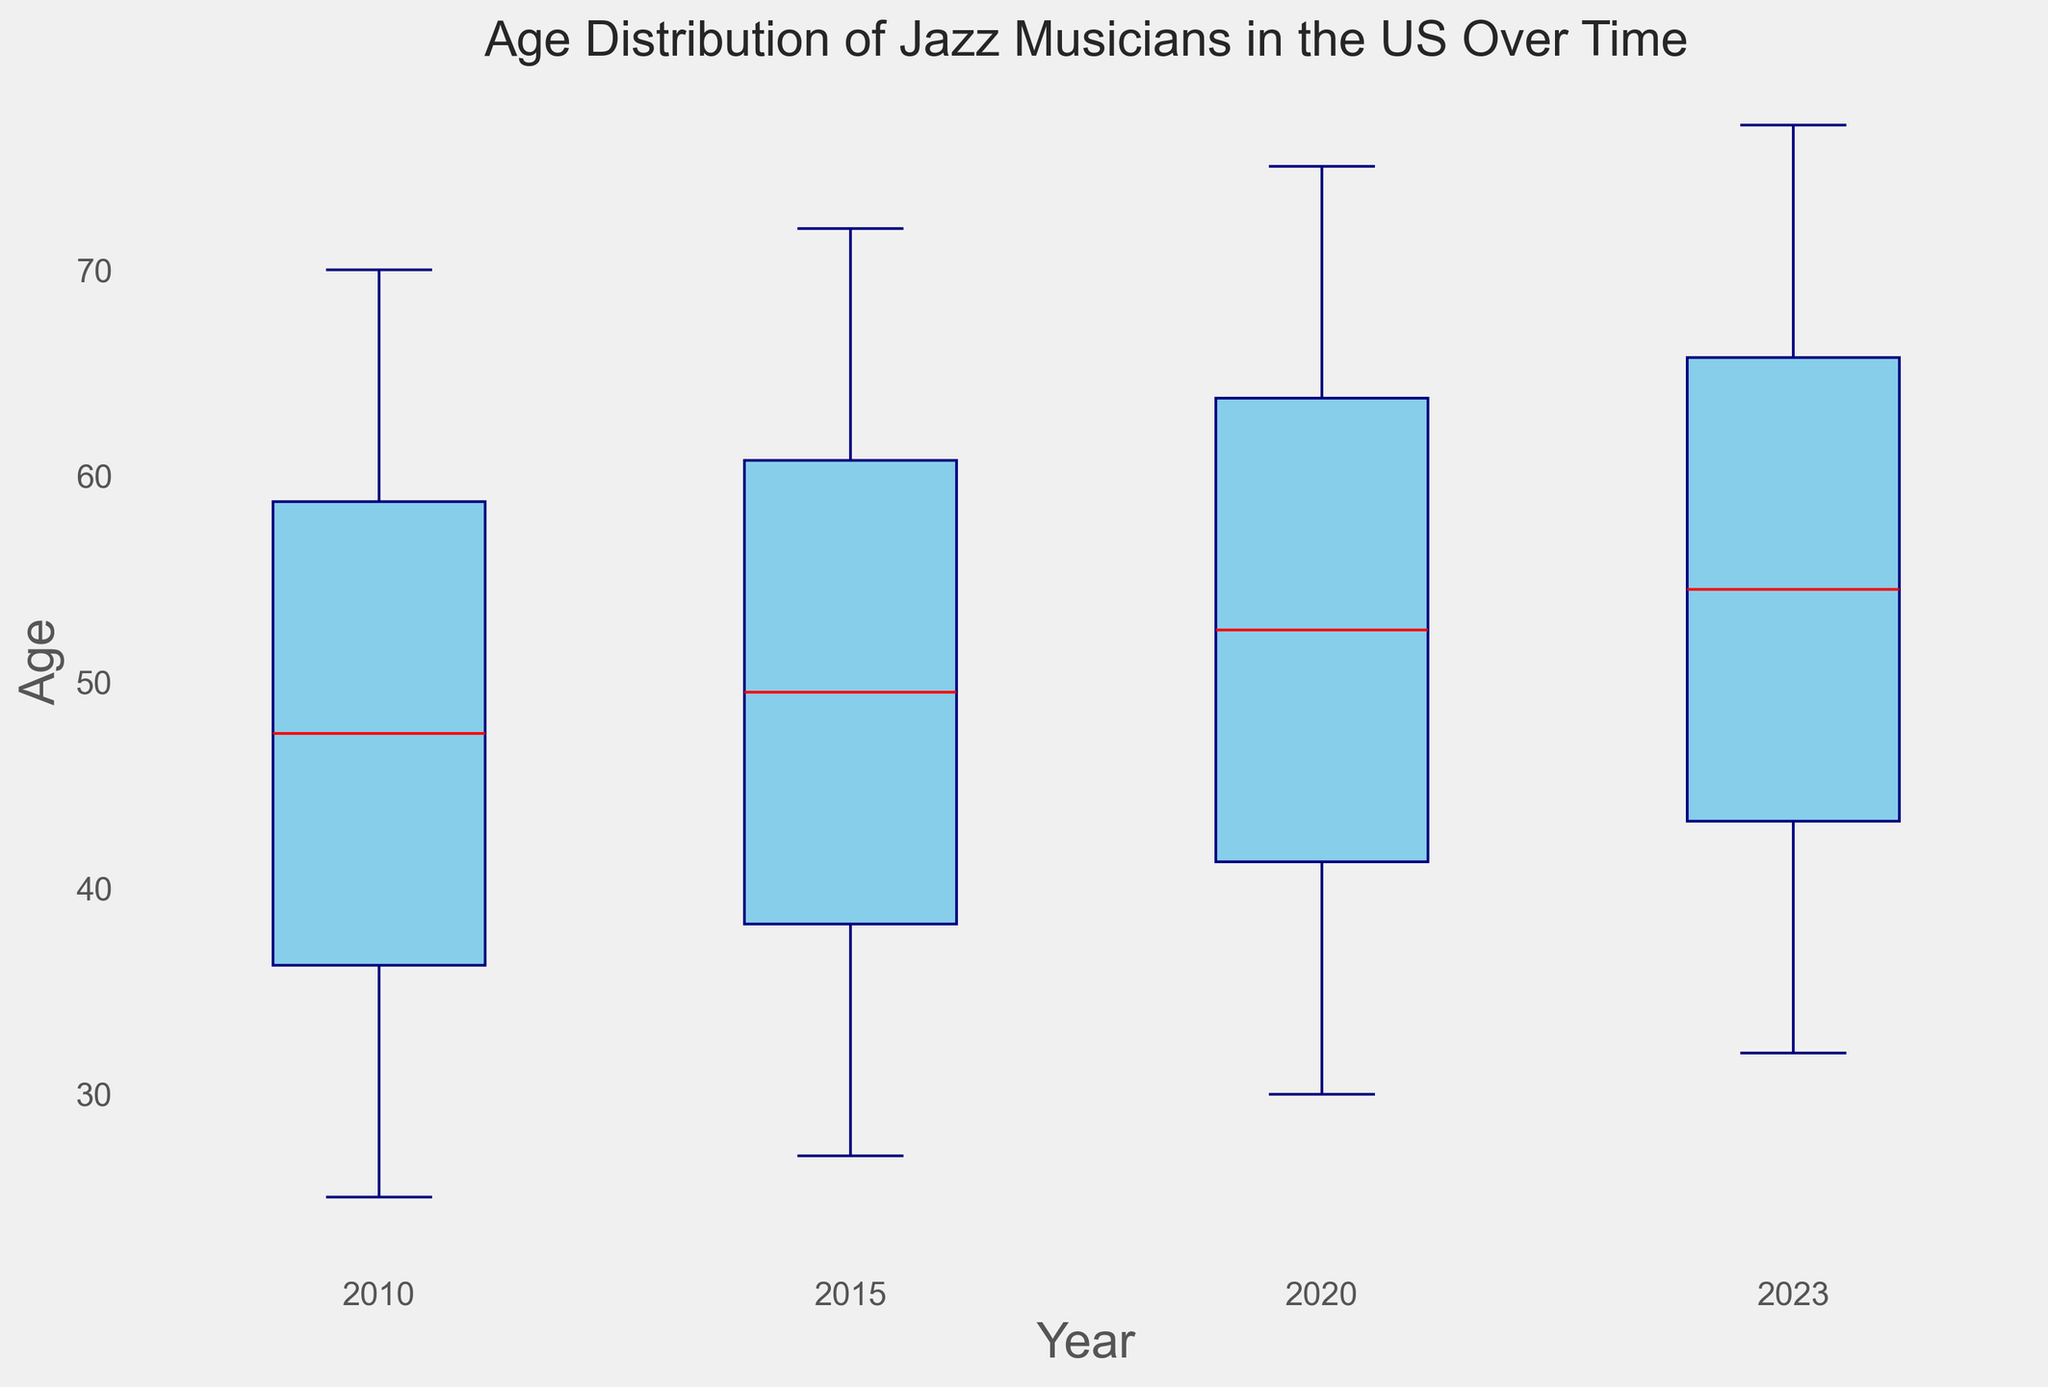What is the median age of Jazz musicians in 2023? The median age in a box plot is represented by the line inside the box for each year. For 2023, this line is located at age 52.
Answer: 52 How does the age distribution range in 2020 compare to 2010? The range in a box plot is determined by the distance between the lower whisker and the upper whisker. In 2010, the range extends from 25 to 70 (70 - 25 = 45 years). In 2020, it spans from 30 to 75 (75 - 30 = 45 years). Both ranges are equal.
Answer: Both ranges are 45 years In which year do Jazz musicians have the highest maximum age? The maximum age can be determined by the highest point of the upper whisker. In 2023, this point is at age 77, which is the highest among all years.
Answer: 2023 Which year has the lowest minimum age for Jazz musicians? The minimum age is represented by the lowest point of the lower whisker. In 2010, this point is at age 25, which is the lowest minimum age among all years displayed.
Answer: 2010 Is the median age of Jazz musicians increasing over time? We observe the median line inside each box for every year. The median age increases from 40 in 2010, to 50 in 2015, to 55 in 2020, and finally to 52 in 2023, with a slight decrease after 2020. Overall, it shows an increasing trend.
Answer: Yes, overall How does the interquartile range (IQR) in 2023 compare to 2015? The IQR is the distance between the first quartile (bottom of the box) and the third quartile (top of the box). For 2015, the IQR is from 42 to 62 (62 - 42 = 20 years). For 2023, it ranges from 42 to 62 (62 - 42 = 20 years). The IQR is the same for both years.
Answer: Both are 20 years Which year shows the greatest variability in Jazz musicians' ages? Variability can be gauged by the range from the lower whisker to the upper whisker. The year with the longest distance between these whiskers indicates the greatest variability. Here, 2020 and 2023 show a range of 45 years each.
Answer: 2020 and 2023 Describe the shift in the age distribution of Jazz musicians from 2010 to 2023. In 2010, the ages range from 25 to 70, with a median of 40. By 2023, the ages span from 32 to 77, and the median is shifted to 52. The interquartile range remains the same but shifted higher.
Answer: Older and shifted higher What is the difference in the median age of Jazz musicians between 2010 and 2020? The median age in 2010 is 40, and the median age in 2020 is 55. The difference between them is 55 - 40 = 15 years.
Answer: 15 years Which year has the most symmetric distribution of ages? Symmetry in the distribution can be inferred by comparing the length of the whiskers and the position of the median within the box. The year 2015 shows the most symmetric distribution as the whiskers and the placement of the median within the box are more balanced as compared to other years.
Answer: 2015 